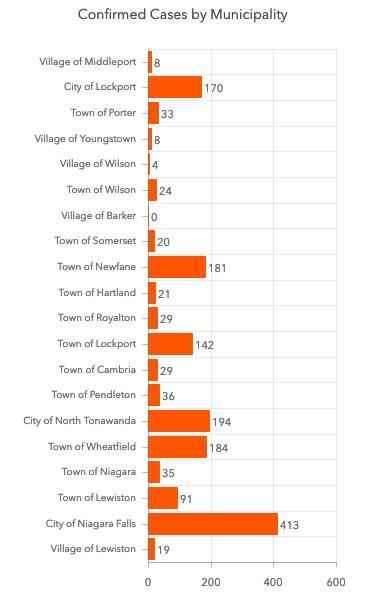How many confirmed COVID-19 cases are reported in the City of Lockport?
Answer the question with a short phrase. 170 What is the number of confirmed COVID-19 cases reported in the Village of Wilson? 4 Which city has reported the highest number of confirmed COVID-19 cases? City of Niagara Falls 